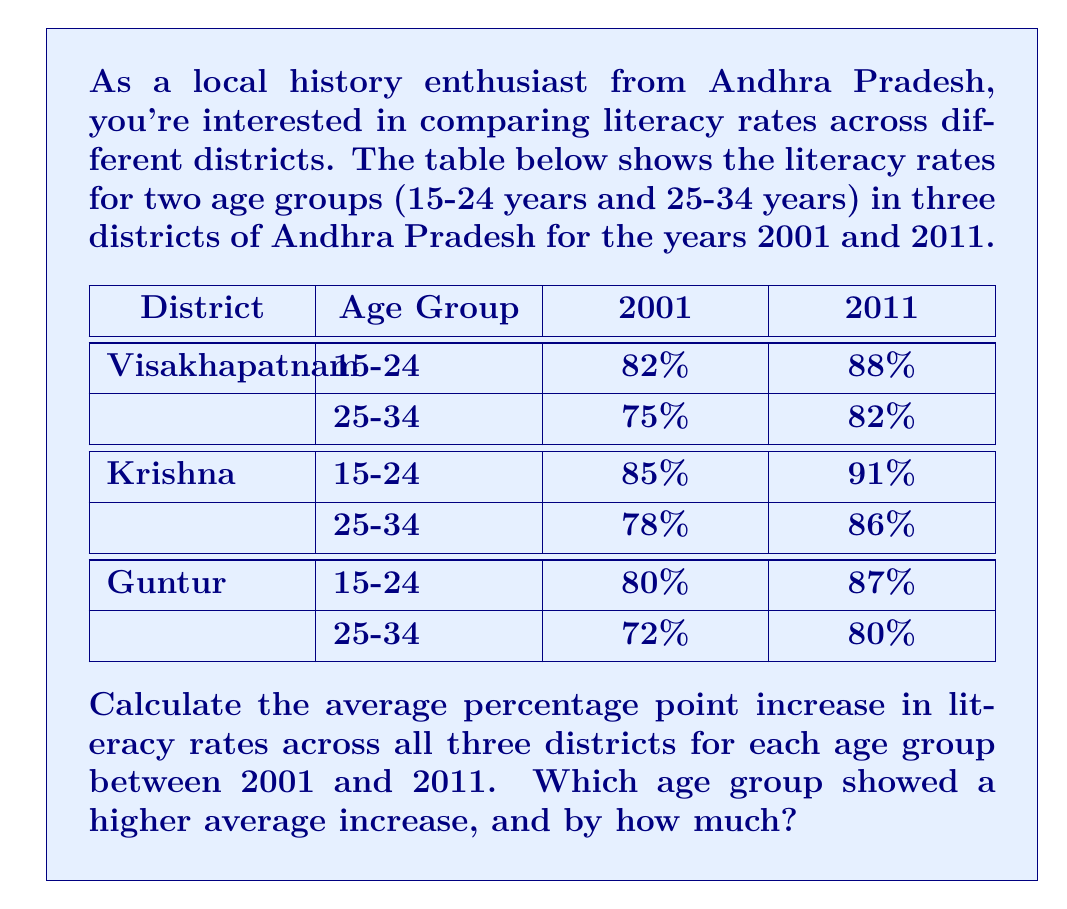Could you help me with this problem? To solve this problem, we need to follow these steps:

1. Calculate the percentage point increase for each district and age group from 2001 to 2011.
2. Find the average increase for each age group across all three districts.
3. Compare the average increases between the two age groups.

Let's go through each step:

1. Percentage point increase for each district and age group:

Visakhapatnam:
15-24: $88\% - 82\% = 6$ percentage points
25-34: $82\% - 75\% = 7$ percentage points

Krishna:
15-24: $91\% - 85\% = 6$ percentage points
25-34: $86\% - 78\% = 8$ percentage points

Guntur:
15-24: $87\% - 80\% = 7$ percentage points
25-34: $80\% - 72\% = 8$ percentage points

2. Average increase for each age group:

For 15-24 age group:
$\text{Average increase} = \frac{6 + 6 + 7}{3} = \frac{19}{3} \approx 6.33$ percentage points

For 25-34 age group:
$\text{Average increase} = \frac{7 + 8 + 8}{3} = \frac{23}{3} \approx 7.67$ percentage points

3. Comparing the average increases:

The 25-34 age group showed a higher average increase.

The difference between the two age groups' average increases:
$7.67 - 6.33 = 1.34$ percentage points

Therefore, the 25-34 age group showed a higher average increase by approximately 1.34 percentage points.
Answer: The 25-34 age group showed a higher average increase in literacy rates, exceeding the 15-24 age group by approximately 1.34 percentage points. 